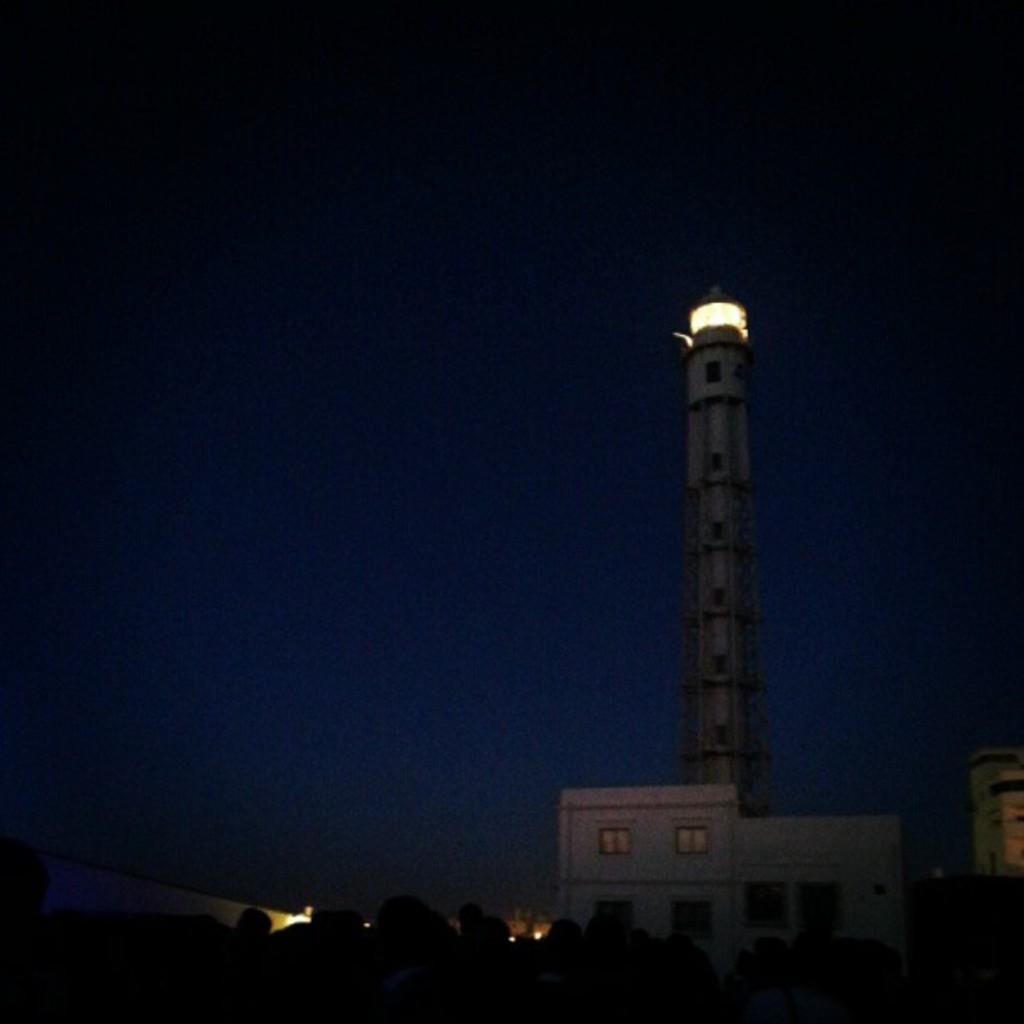What is the main structure in the image? There is a lighthouse in the image. Are there any other buildings or structures visible? Yes, there are buildings in the image. What is the lighting condition at the bottom of the image? The bottom of the image has a dark view. What can be seen in the background of the image? The sky is visible in the background of the image. Where is the car parked for the party in the image? There is no car or party present in the image; it features a lighthouse and buildings. What memories does the lighthouse evoke for the person in the image? The image does not show a person, and therefore it cannot be determined what memories the lighthouse might evoke. 